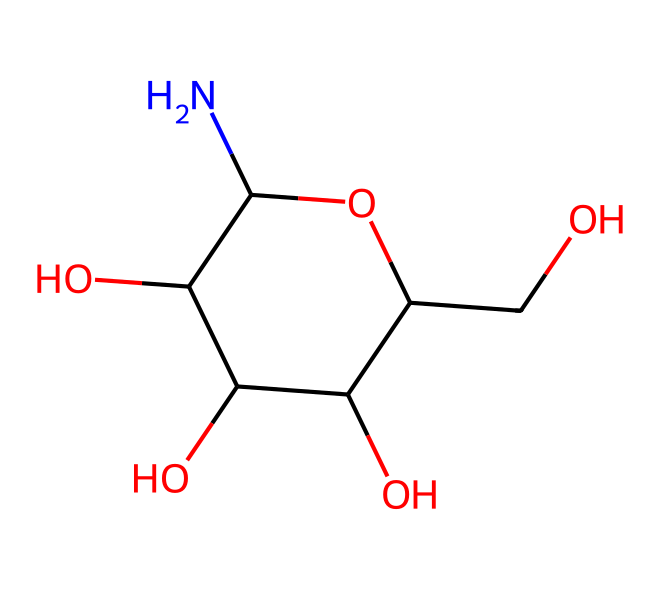What is the common name of the chemical represented by this structure? This structure corresponds to the compound known for its role in joint health. It is commonly referred to as glucosamine.
Answer: glucosamine How many carbon atoms are present in the structure? By counting the 'C' symbols in the SMILES, there are 6 carbon atoms in the structure.
Answer: 6 Does this chemical contain nitrogen? The presence of 'N' in the SMILES indicates that there is one nitrogen atom in the structure.
Answer: yes What type of molecule is glucosamine classified as? Glucosamine is classified as an amino sugar due to the presence of both an amine group (NH2) and a sugar ( carbohydrate backbone).
Answer: amino sugar How many hydroxyl (–OH) groups are present in the structure? Upon examining the structure, there are four hydroxyl groups identified, represented by the 'O' in the SMILES interacting with hydrogen.
Answer: 4 Which part of glucosamine is responsible for its acidic properties? The hydroxyl groups contribute to the acidic characteristics by providing potential for proton donation. While glucosamine is not highly acidic, these functional groups are to be attributed.
Answer: hydroxyl groups What is the primary biological function of glucosamine? Glucosamine primarily supports joint health and is involved in the synthesis of glycosaminoglycans which are components of cartilage.
Answer: joint health 